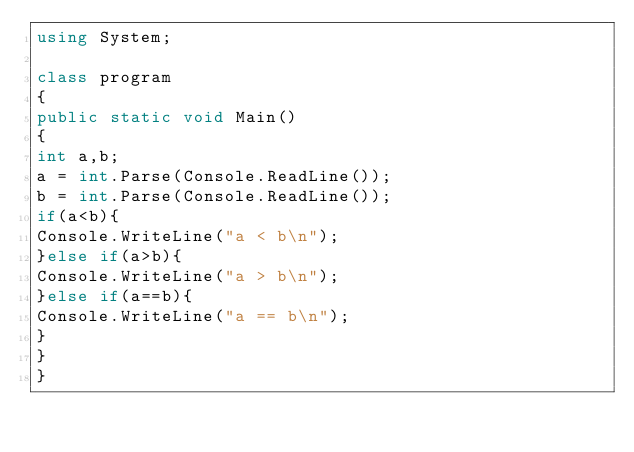Convert code to text. <code><loc_0><loc_0><loc_500><loc_500><_C#_>using System;

class program
{
public static void Main()
{
int a,b;
a = int.Parse(Console.ReadLine());
b = int.Parse(Console.ReadLine());
if(a<b){
Console.WriteLine("a < b\n");
}else if(a>b){
Console.WriteLine("a > b\n");
}else if(a==b){
Console.WriteLine("a == b\n");
}
}
}</code> 